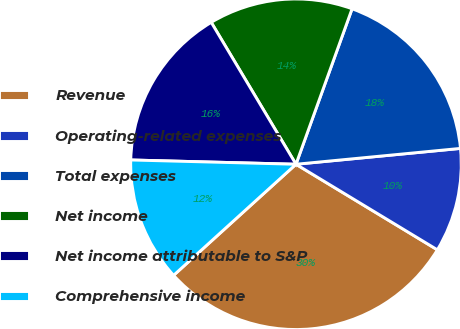<chart> <loc_0><loc_0><loc_500><loc_500><pie_chart><fcel>Revenue<fcel>Operating-related expenses<fcel>Total expenses<fcel>Net income<fcel>Net income attributable to S&P<fcel>Comprehensive income<nl><fcel>29.61%<fcel>10.19%<fcel>17.96%<fcel>14.08%<fcel>16.02%<fcel>12.14%<nl></chart> 